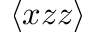Convert formula to latex. <formula><loc_0><loc_0><loc_500><loc_500>\langle x z z \rangle</formula> 